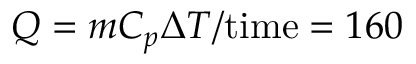<formula> <loc_0><loc_0><loc_500><loc_500>Q = m C _ { p } \Delta T / t i m e = 1 6 0</formula> 